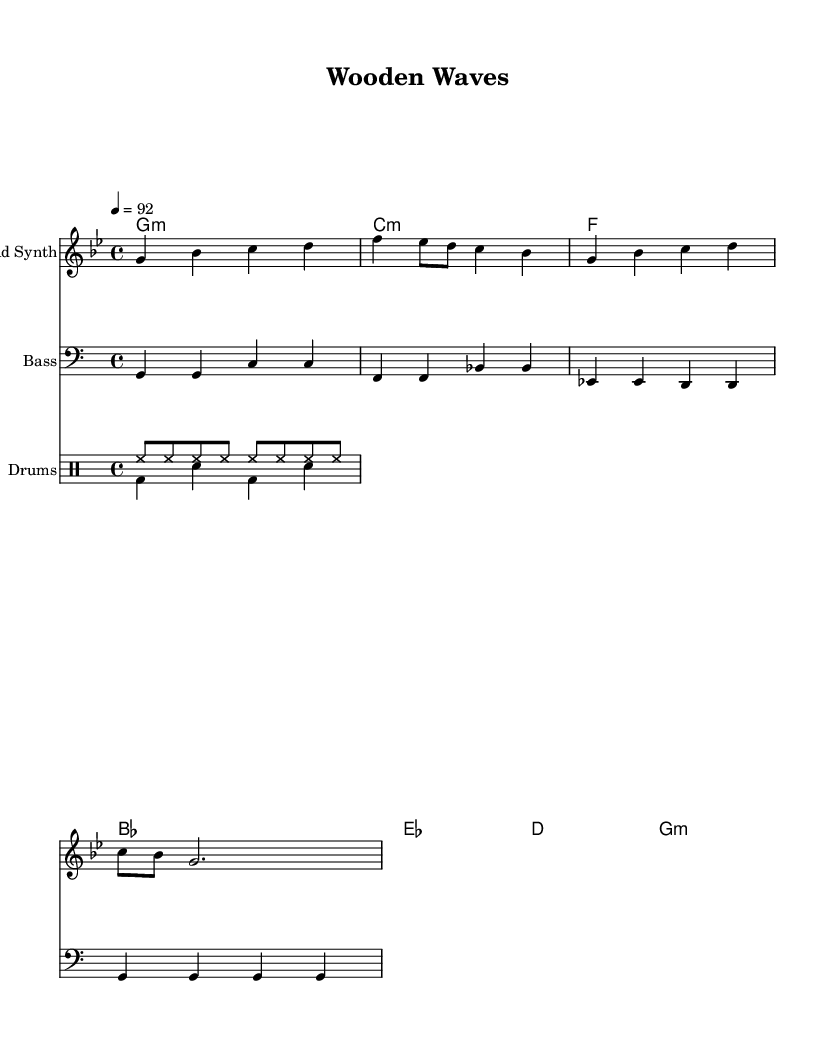What is the key signature of this music? The key signature is G minor, which has two flats (B flat and E flat) indicated on the staff.
Answer: G minor What is the time signature of this music? The time signature is indicated at the beginning of the piece as 4/4, meaning there are four beats in a measure and a quarter note receives one beat.
Answer: 4/4 What is the tempo marking of this music? The tempo marking is indicated as quarter note equals 92, which tells the musician how fast to play, with 92 beats per minute.
Answer: 92 How many measures are in the melody line? Counting the measures in the melody line, there are a total of 4 measures present in this section.
Answer: 4 What type of beats are used in the drum pattern? The drum pattern features a combination of hi-hats and bass drum, specifically a repeated eighth note for hi-hats and alternating quarter notes for bass drum.
Answer: Hi-hats and bass drum What is the structure of the harmonies in this piece? The harmonies are written in chord mode and consist of a sequence that includes G minor, C minor, F major, and B flat major, among others, creating a cohesive progression.
Answer: G minor, C minor, F, B flat What is the primary instrument indicated in the lead staff? The primary instrument in the lead staff is designated as "Lead Synth," which indicates the melody will be played with a synthesizer sound.
Answer: Lead Synth 